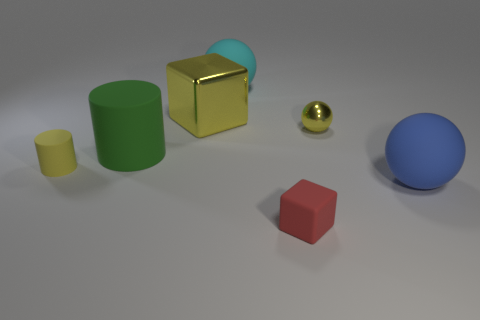Add 2 large blue rubber spheres. How many objects exist? 9 Subtract all spheres. How many objects are left? 4 Subtract 0 purple spheres. How many objects are left? 7 Subtract all yellow matte objects. Subtract all cubes. How many objects are left? 4 Add 7 large balls. How many large balls are left? 9 Add 4 tiny rubber objects. How many tiny rubber objects exist? 6 